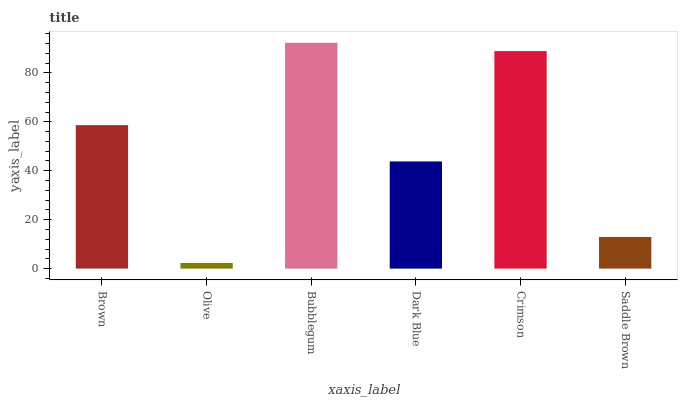Is Olive the minimum?
Answer yes or no. Yes. Is Bubblegum the maximum?
Answer yes or no. Yes. Is Bubblegum the minimum?
Answer yes or no. No. Is Olive the maximum?
Answer yes or no. No. Is Bubblegum greater than Olive?
Answer yes or no. Yes. Is Olive less than Bubblegum?
Answer yes or no. Yes. Is Olive greater than Bubblegum?
Answer yes or no. No. Is Bubblegum less than Olive?
Answer yes or no. No. Is Brown the high median?
Answer yes or no. Yes. Is Dark Blue the low median?
Answer yes or no. Yes. Is Bubblegum the high median?
Answer yes or no. No. Is Brown the low median?
Answer yes or no. No. 